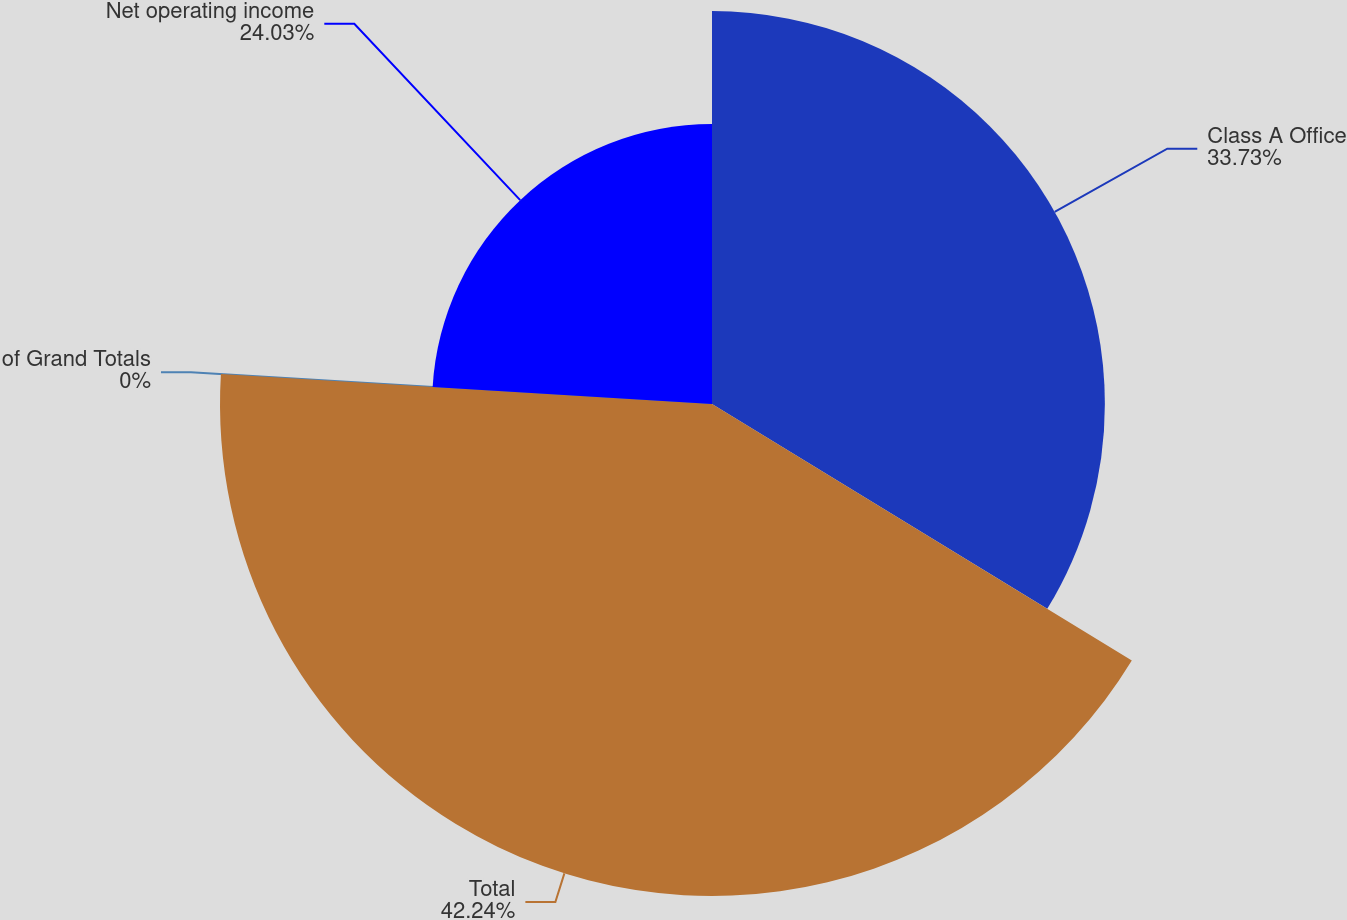Convert chart to OTSL. <chart><loc_0><loc_0><loc_500><loc_500><pie_chart><fcel>Class A Office<fcel>Total<fcel>of Grand Totals<fcel>Net operating income<nl><fcel>33.73%<fcel>42.24%<fcel>0.0%<fcel>24.03%<nl></chart> 